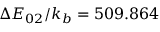Convert formula to latex. <formula><loc_0><loc_0><loc_500><loc_500>\Delta E _ { 0 2 } / k _ { b } = 5 0 9 . 8 6 4</formula> 